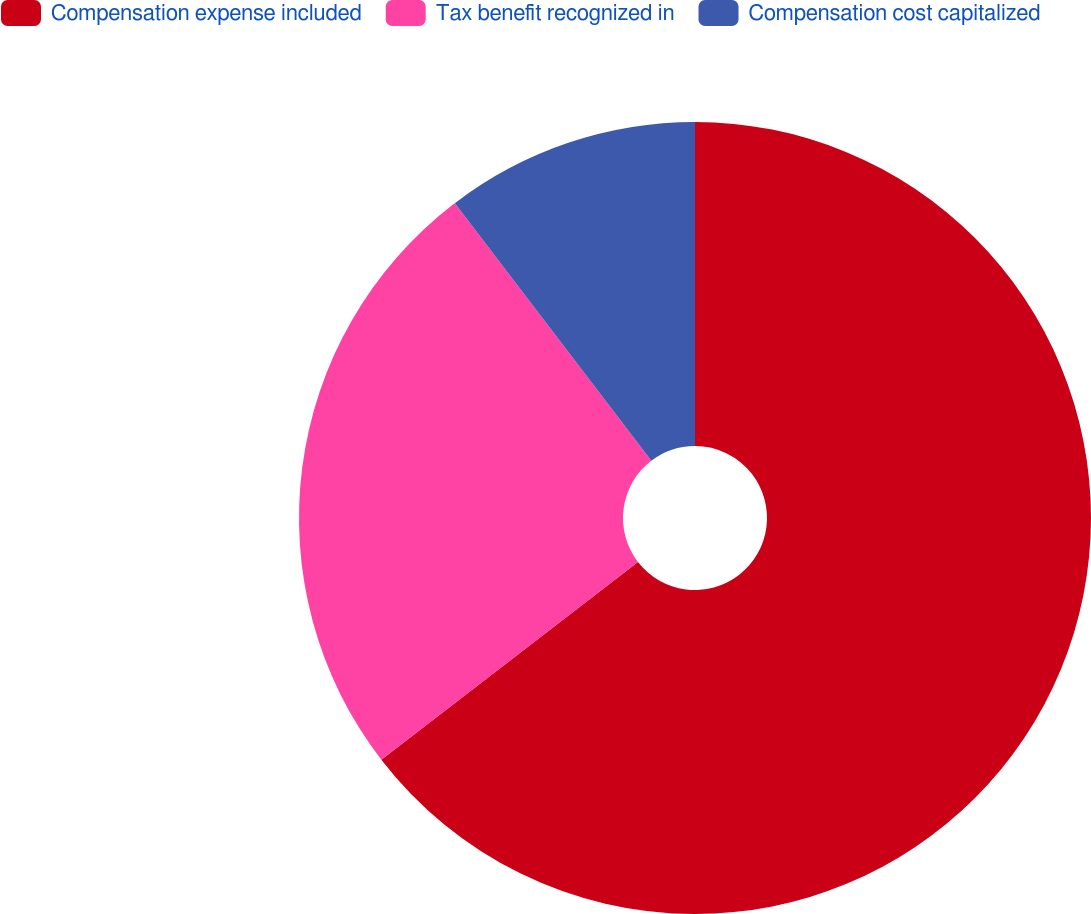Convert chart. <chart><loc_0><loc_0><loc_500><loc_500><pie_chart><fcel>Compensation expense included<fcel>Tax benefit recognized in<fcel>Compensation cost capitalized<nl><fcel>64.55%<fcel>25.08%<fcel>10.37%<nl></chart> 